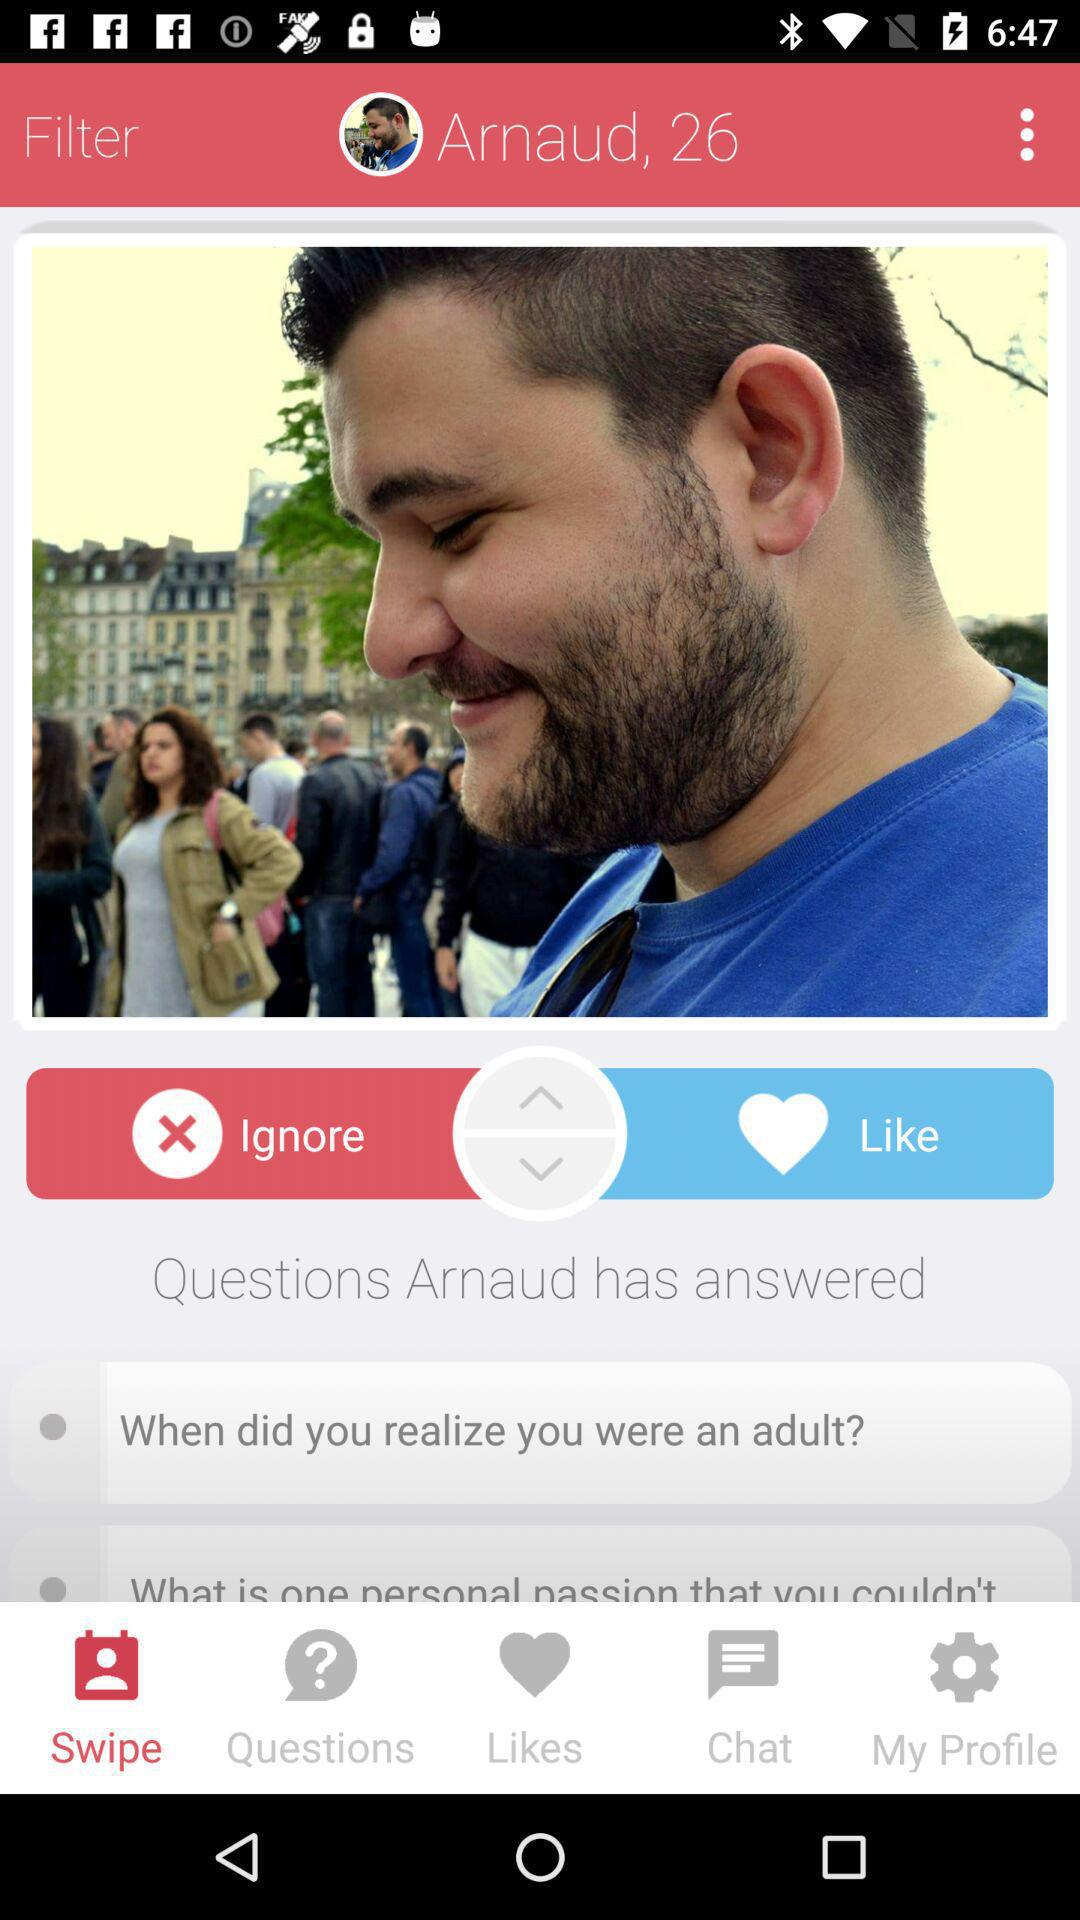What is the user name? The user name is Arnaud. 